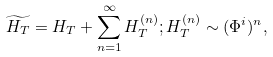Convert formula to latex. <formula><loc_0><loc_0><loc_500><loc_500>\widetilde { H _ { T } } = H _ { T } + \sum _ { n = 1 } ^ { \infty } H _ { T } ^ { ( n ) } ; H _ { T } ^ { ( n ) } \sim ( \Phi ^ { i } ) ^ { n } ,</formula> 